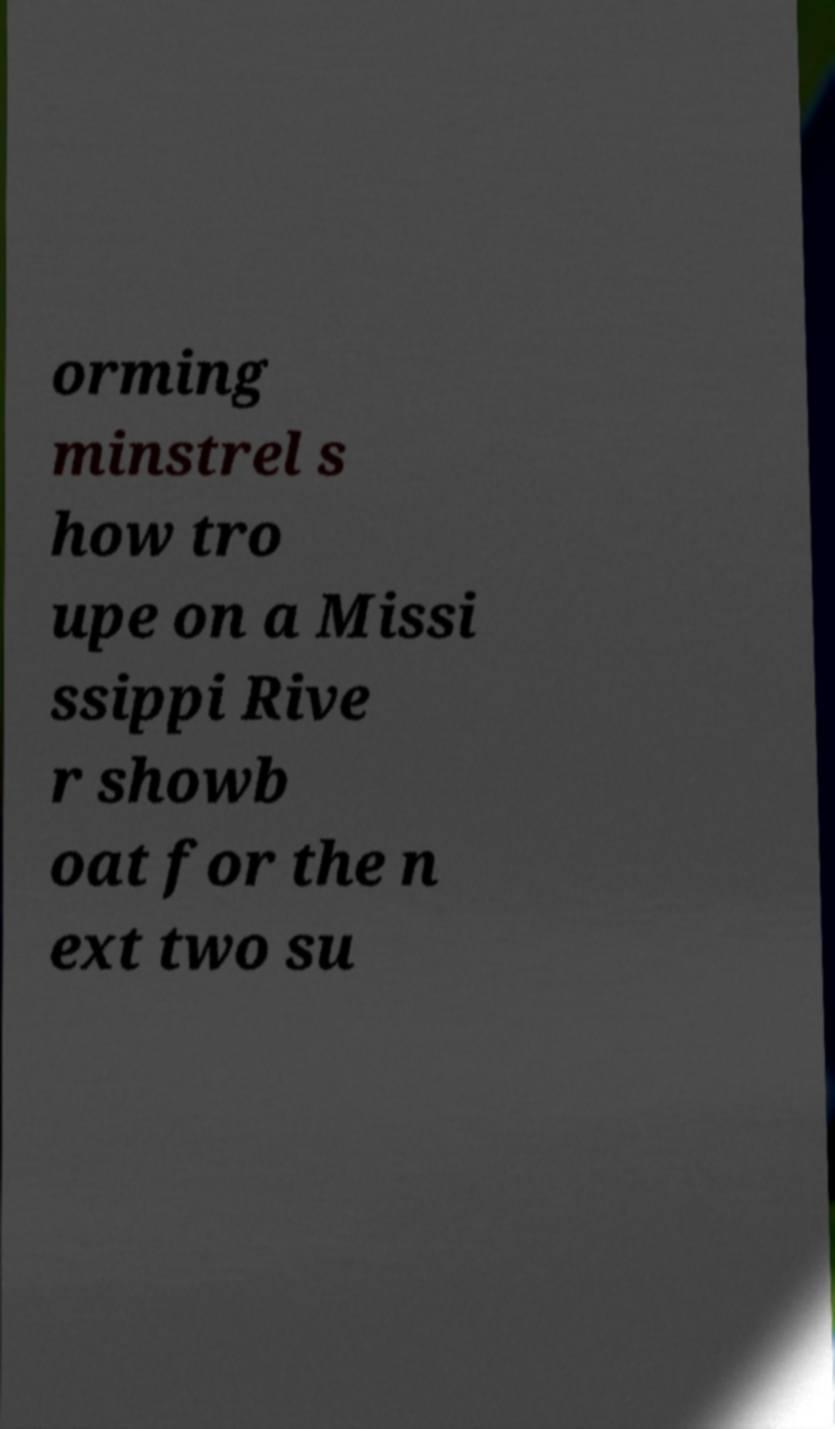What messages or text are displayed in this image? I need them in a readable, typed format. orming minstrel s how tro upe on a Missi ssippi Rive r showb oat for the n ext two su 